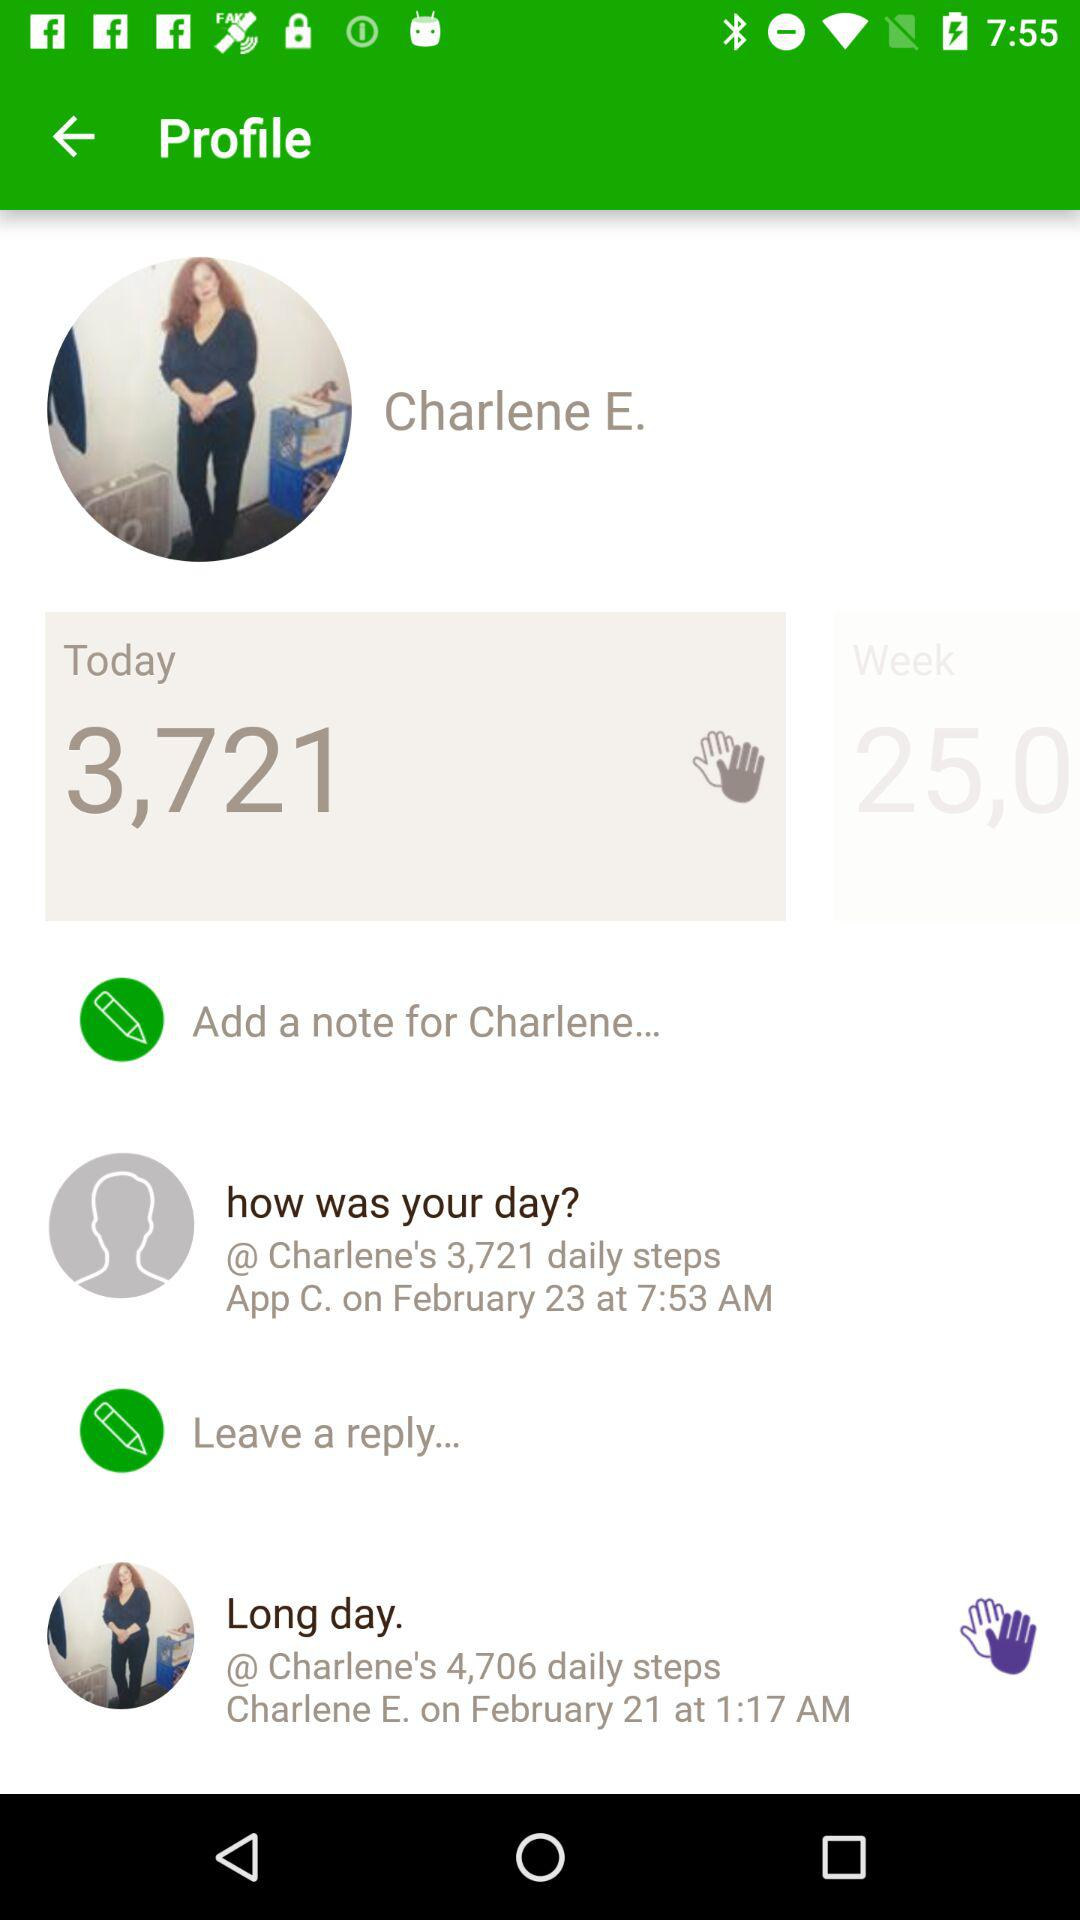How many steps are done today? There are 3,721 steps done today. 